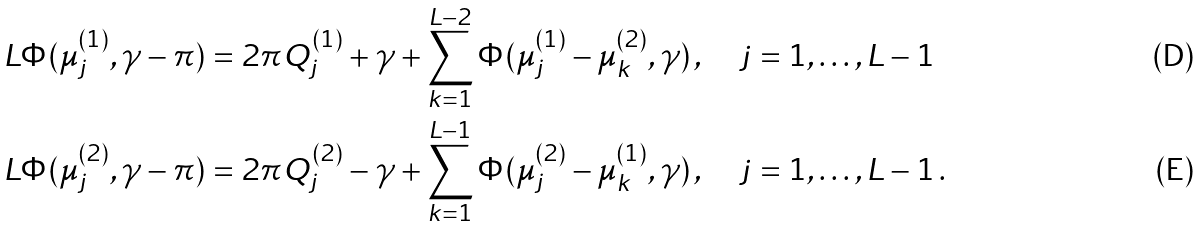<formula> <loc_0><loc_0><loc_500><loc_500>L \Phi ( \mu _ { j } ^ { ( 1 ) } , \gamma - \pi ) & = 2 \pi Q _ { j } ^ { ( 1 ) } + \gamma + \sum _ { k = 1 } ^ { L - 2 } \Phi ( \mu _ { j } ^ { ( 1 ) } - \mu _ { k } ^ { ( 2 ) } , \gamma ) \, , \quad j = 1 , \dots , L - 1 \\ L \Phi ( \mu _ { j } ^ { ( 2 ) } , \gamma - \pi ) & = 2 \pi Q _ { j } ^ { ( 2 ) } - \gamma + \sum _ { k = 1 } ^ { L - 1 } \Phi ( \mu _ { j } ^ { ( 2 ) } - \mu _ { k } ^ { ( 1 ) } , \gamma ) \, , \quad j = 1 , \dots , L - 1 \, .</formula> 